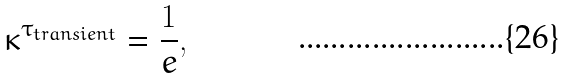<formula> <loc_0><loc_0><loc_500><loc_500>\kappa ^ { \tau _ { t r a n s i e n t } } = \frac { 1 } { e } ,</formula> 